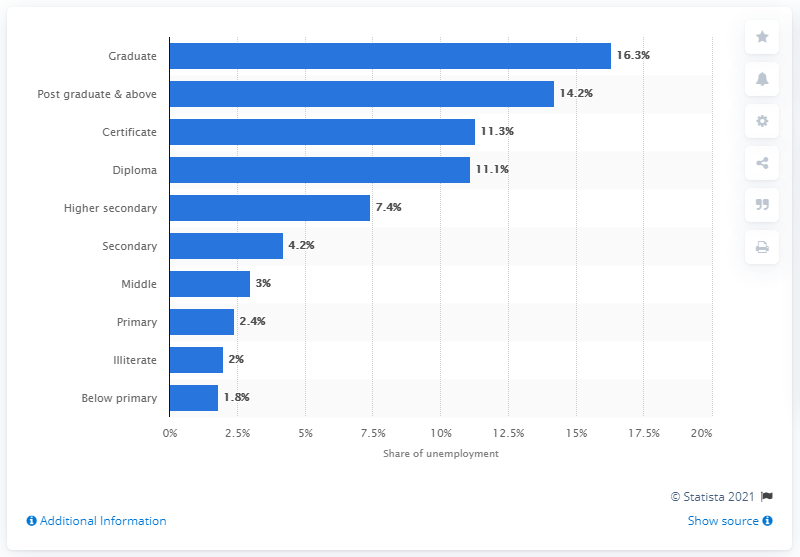What can we infer about the relationship between education and employability from the bar graph? From the bar graph, it can be inferred that higher education does not necessarily correlate with better employability. In fact, the group with the highest unemployment rate is that of graduates, while those with lower educational qualifications tend to have lower unemployment rates, challenging the common assumption that higher education always leads to better job prospects. 